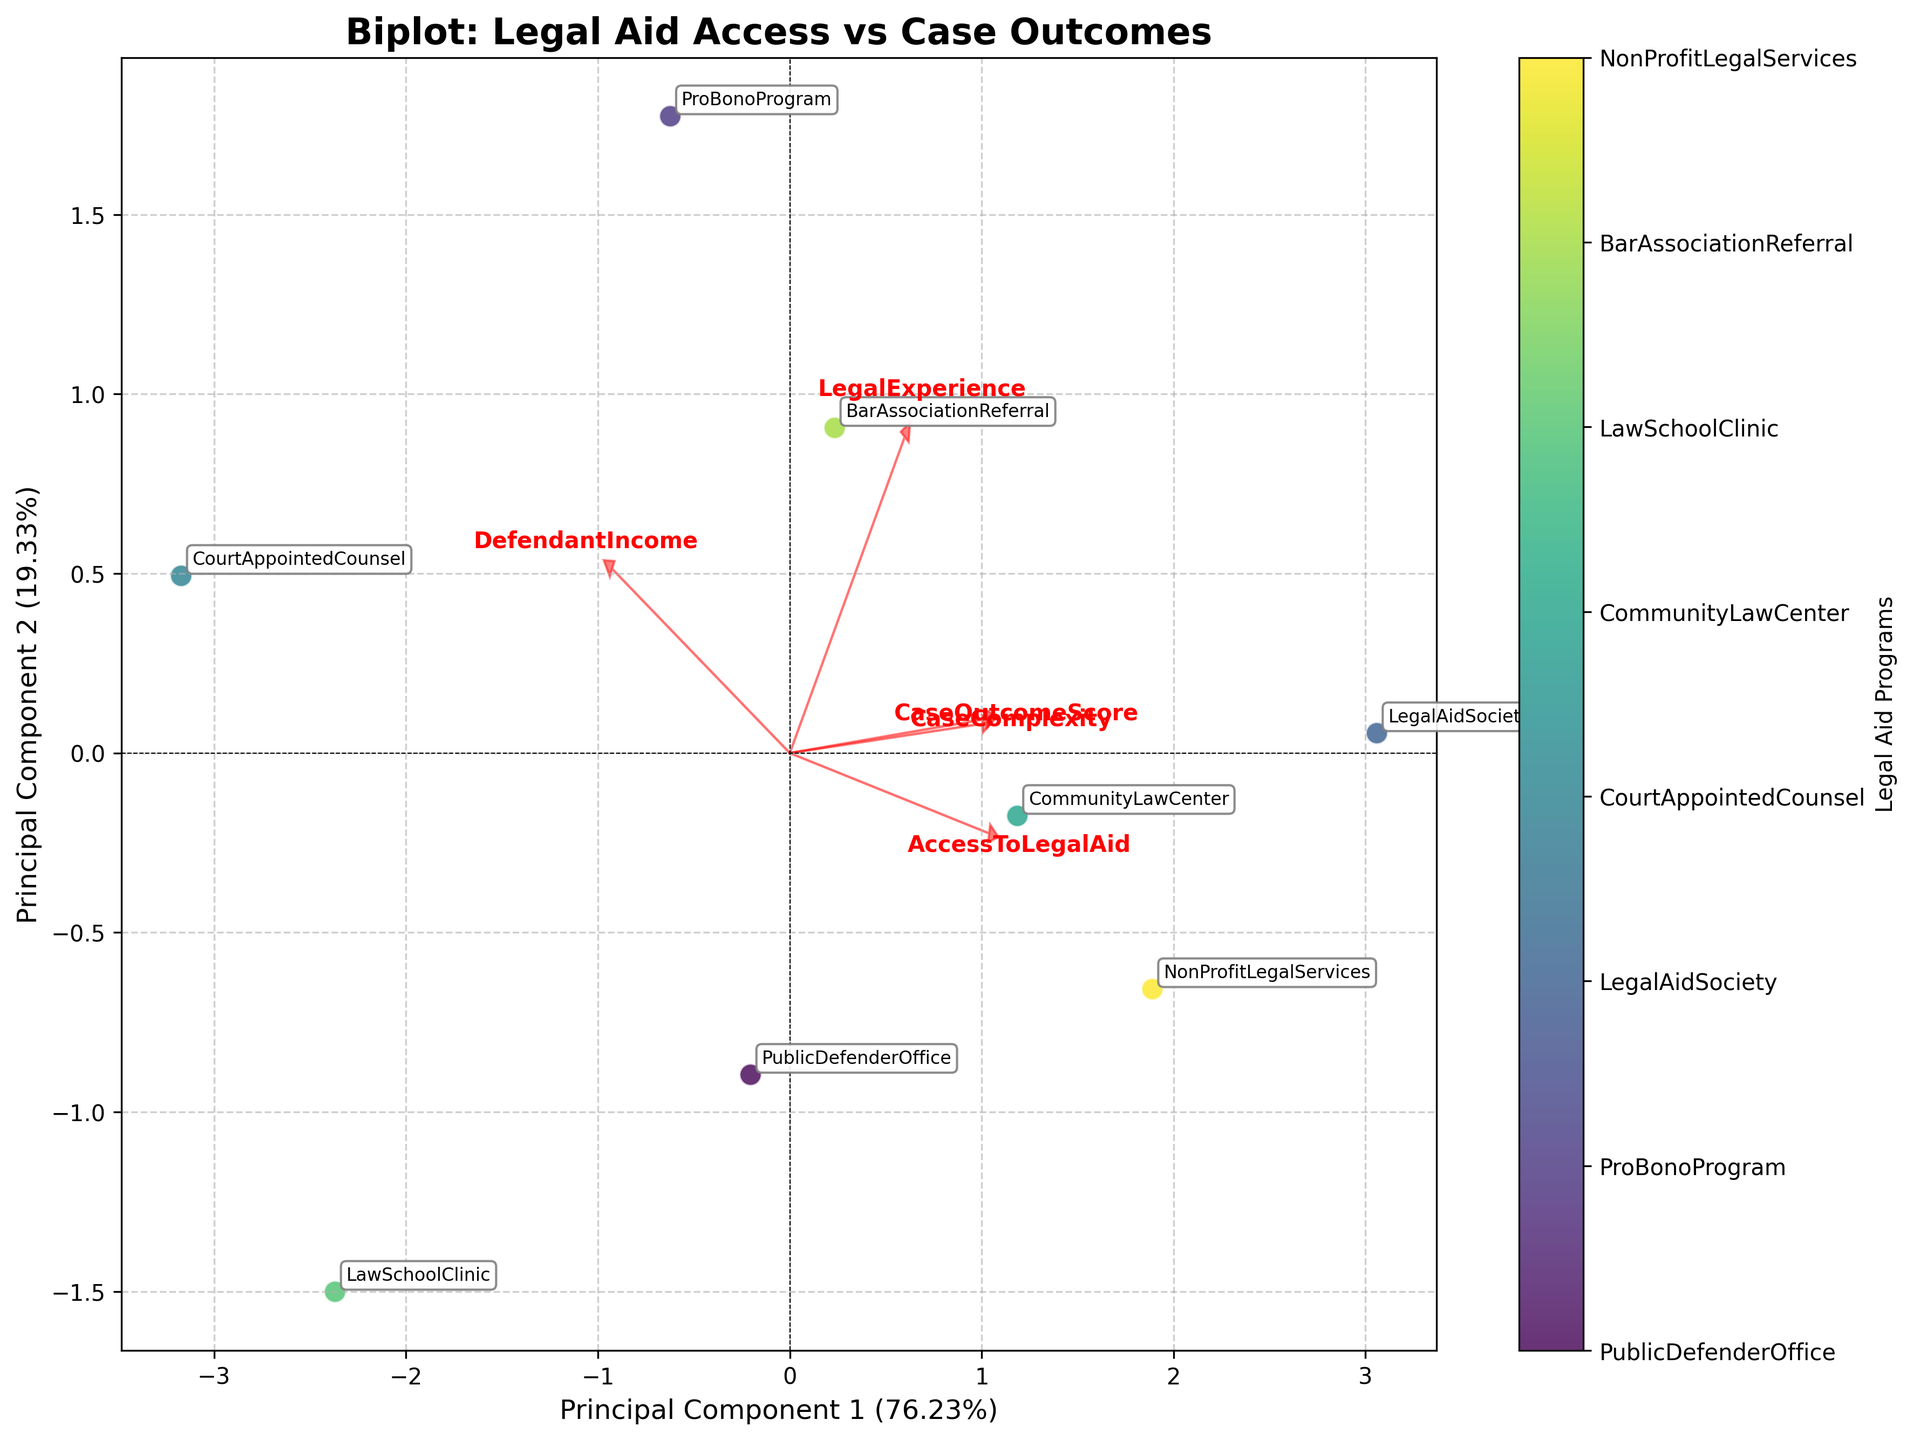How many legal aid programs are represented in the plot? We count the distinct data points labeled in the biplot to determine the number of legal aid programs represented.
Answer: 8 What is the title of the biplot? The title is prominently displayed at the top of the biplot.
Answer: Biplot: Legal Aid Access vs Case Outcomes Which principal component explains more variance? By examining the axis labels, we observe the percentage of variance explained by each principal component. The component with the higher percentage explains more variance.
Answer: Principal Component 1 Which legal aid program is farthest to the right on the x-axis? We look at the data points and identify the one positioned farthest to the right on the x-axis.
Answer: Legal Aid Society Which feature's vector points more towards the positive y-axis? By inspecting the loadings, we determine which feature's vector has the most significant component in the positive y-axis direction.
Answer: CaseOutcomeScore Which legal aid program is closest to the origin (0, 0) on the biplot? By comparing the distances of all data points from the origin, we identify the one closest to (0, 0).
Answer: Court Appointed Counsel What does the text '8.2%' on the x-axis label refer to? The text on the x-axis label refers to the percentage of variance explained by Principal Component 1 as explained in the axis label.
Answer: Percentage of variance explained by Principal Component 1 Which feature is most closely associated with Principal Component 2? The feature with the longest vector pointing in the direction of Principal Component 2 is the most closely associated feature.
Answer: CaseOutcomeScore Between "ProBonoProgram" and "CommunityLawCenter," which has a higher case outcome score? We compare the y-axis locations (case outcome scores) of the two labeled points to determine which is higher.
Answer: ProBonoProgram What explains the variation among the legal aid programs as depicted in the biplot? The vectors (loadings) on the biplot represent different features that contribute to the variation among the legal aid programs. These features include AccessToLegalAid, CaseOutcomeScore, LegalExperience, CaseComplexity, and DefendantIncome. By observing the directions and lengths of these vectors, we determine how each feature influences the placement and differentiation of the legal aid programs on the plot. Longer vectors indicate stronger influence, and the direction of the vectors shows the trend or association of each feature in relation to the principal components and the legal aid programs.
Answer: The variability is explained by AccessToLegalAid, CaseOutcomeScore, LegalExperience, CaseComplexity, and DefendantIncome 